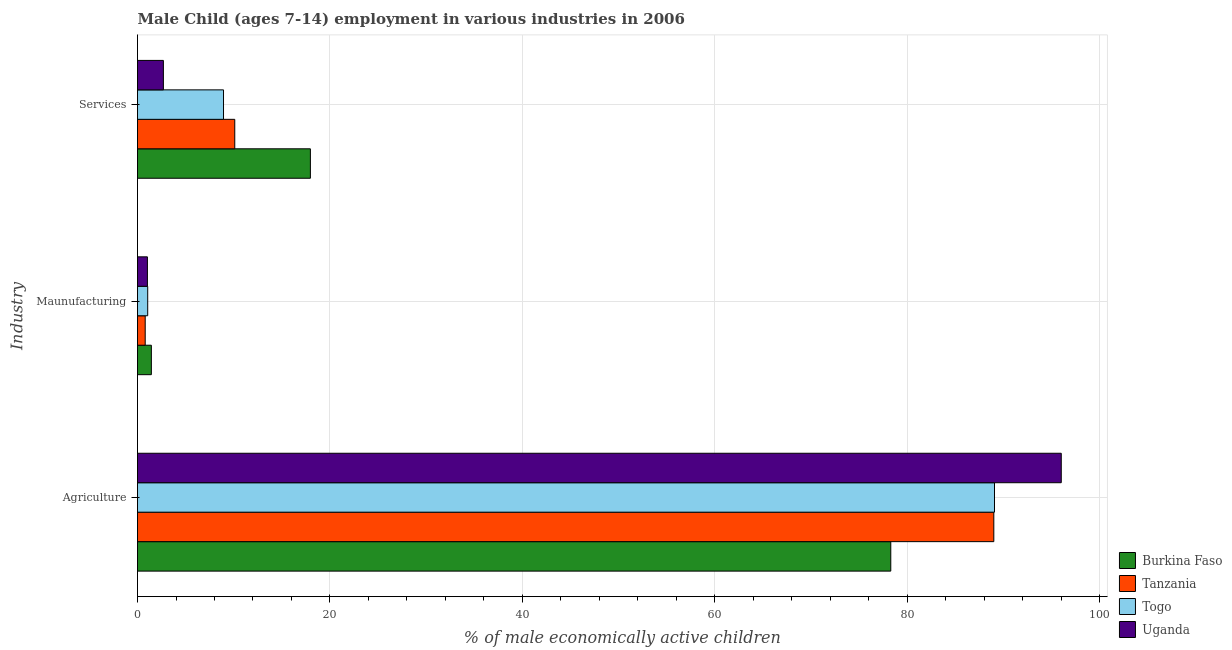How many bars are there on the 2nd tick from the top?
Give a very brief answer. 4. What is the label of the 1st group of bars from the top?
Provide a short and direct response. Services. What is the percentage of economically active children in services in Togo?
Your answer should be compact. 8.94. Across all countries, what is the maximum percentage of economically active children in agriculture?
Ensure brevity in your answer.  96.02. Across all countries, what is the minimum percentage of economically active children in services?
Keep it short and to the point. 2.69. In which country was the percentage of economically active children in agriculture maximum?
Provide a short and direct response. Uganda. In which country was the percentage of economically active children in agriculture minimum?
Your answer should be very brief. Burkina Faso. What is the total percentage of economically active children in manufacturing in the graph?
Provide a succinct answer. 4.33. What is the difference between the percentage of economically active children in services in Togo and that in Tanzania?
Provide a succinct answer. -1.17. What is the difference between the percentage of economically active children in manufacturing in Togo and the percentage of economically active children in agriculture in Burkina Faso?
Ensure brevity in your answer.  -77.24. What is the average percentage of economically active children in manufacturing per country?
Keep it short and to the point. 1.08. What is the difference between the percentage of economically active children in services and percentage of economically active children in manufacturing in Uganda?
Your answer should be compact. 1.66. What is the ratio of the percentage of economically active children in services in Togo to that in Uganda?
Give a very brief answer. 3.32. Is the percentage of economically active children in manufacturing in Tanzania less than that in Togo?
Your answer should be very brief. Yes. What is the difference between the highest and the second highest percentage of economically active children in manufacturing?
Keep it short and to the point. 0.38. What is the difference between the highest and the lowest percentage of economically active children in manufacturing?
Your answer should be compact. 0.64. Is the sum of the percentage of economically active children in agriculture in Burkina Faso and Tanzania greater than the maximum percentage of economically active children in services across all countries?
Your response must be concise. Yes. What does the 4th bar from the top in Agriculture represents?
Your answer should be very brief. Burkina Faso. What does the 3rd bar from the bottom in Agriculture represents?
Offer a very short reply. Togo. How many bars are there?
Your response must be concise. 12. How many countries are there in the graph?
Offer a very short reply. 4. Are the values on the major ticks of X-axis written in scientific E-notation?
Ensure brevity in your answer.  No. Does the graph contain any zero values?
Give a very brief answer. No. How are the legend labels stacked?
Give a very brief answer. Vertical. What is the title of the graph?
Your response must be concise. Male Child (ages 7-14) employment in various industries in 2006. Does "South Africa" appear as one of the legend labels in the graph?
Provide a short and direct response. No. What is the label or title of the X-axis?
Offer a terse response. % of male economically active children. What is the label or title of the Y-axis?
Give a very brief answer. Industry. What is the % of male economically active children in Burkina Faso in Agriculture?
Your response must be concise. 78.3. What is the % of male economically active children of Tanzania in Agriculture?
Your answer should be compact. 89.01. What is the % of male economically active children in Togo in Agriculture?
Offer a terse response. 89.08. What is the % of male economically active children of Uganda in Agriculture?
Provide a succinct answer. 96.02. What is the % of male economically active children of Burkina Faso in Maunufacturing?
Offer a terse response. 1.44. What is the % of male economically active children in Tanzania in Maunufacturing?
Ensure brevity in your answer.  0.8. What is the % of male economically active children of Togo in Maunufacturing?
Your answer should be very brief. 1.06. What is the % of male economically active children of Uganda in Maunufacturing?
Your answer should be very brief. 1.03. What is the % of male economically active children of Burkina Faso in Services?
Keep it short and to the point. 17.97. What is the % of male economically active children of Tanzania in Services?
Ensure brevity in your answer.  10.11. What is the % of male economically active children in Togo in Services?
Ensure brevity in your answer.  8.94. What is the % of male economically active children in Uganda in Services?
Your answer should be very brief. 2.69. Across all Industry, what is the maximum % of male economically active children of Burkina Faso?
Provide a succinct answer. 78.3. Across all Industry, what is the maximum % of male economically active children of Tanzania?
Your answer should be very brief. 89.01. Across all Industry, what is the maximum % of male economically active children in Togo?
Provide a succinct answer. 89.08. Across all Industry, what is the maximum % of male economically active children of Uganda?
Offer a very short reply. 96.02. Across all Industry, what is the minimum % of male economically active children of Burkina Faso?
Offer a terse response. 1.44. Across all Industry, what is the minimum % of male economically active children in Togo?
Your response must be concise. 1.06. What is the total % of male economically active children in Burkina Faso in the graph?
Keep it short and to the point. 97.71. What is the total % of male economically active children of Tanzania in the graph?
Your answer should be very brief. 99.92. What is the total % of male economically active children of Togo in the graph?
Provide a succinct answer. 99.08. What is the total % of male economically active children of Uganda in the graph?
Give a very brief answer. 99.74. What is the difference between the % of male economically active children in Burkina Faso in Agriculture and that in Maunufacturing?
Offer a terse response. 76.86. What is the difference between the % of male economically active children of Tanzania in Agriculture and that in Maunufacturing?
Make the answer very short. 88.21. What is the difference between the % of male economically active children in Togo in Agriculture and that in Maunufacturing?
Your response must be concise. 88.02. What is the difference between the % of male economically active children in Uganda in Agriculture and that in Maunufacturing?
Your response must be concise. 94.99. What is the difference between the % of male economically active children of Burkina Faso in Agriculture and that in Services?
Make the answer very short. 60.33. What is the difference between the % of male economically active children of Tanzania in Agriculture and that in Services?
Offer a very short reply. 78.9. What is the difference between the % of male economically active children in Togo in Agriculture and that in Services?
Make the answer very short. 80.14. What is the difference between the % of male economically active children of Uganda in Agriculture and that in Services?
Ensure brevity in your answer.  93.33. What is the difference between the % of male economically active children of Burkina Faso in Maunufacturing and that in Services?
Provide a succinct answer. -16.53. What is the difference between the % of male economically active children in Tanzania in Maunufacturing and that in Services?
Provide a short and direct response. -9.31. What is the difference between the % of male economically active children of Togo in Maunufacturing and that in Services?
Provide a short and direct response. -7.88. What is the difference between the % of male economically active children in Uganda in Maunufacturing and that in Services?
Provide a succinct answer. -1.66. What is the difference between the % of male economically active children of Burkina Faso in Agriculture and the % of male economically active children of Tanzania in Maunufacturing?
Offer a terse response. 77.5. What is the difference between the % of male economically active children in Burkina Faso in Agriculture and the % of male economically active children in Togo in Maunufacturing?
Keep it short and to the point. 77.24. What is the difference between the % of male economically active children in Burkina Faso in Agriculture and the % of male economically active children in Uganda in Maunufacturing?
Provide a succinct answer. 77.27. What is the difference between the % of male economically active children in Tanzania in Agriculture and the % of male economically active children in Togo in Maunufacturing?
Give a very brief answer. 87.95. What is the difference between the % of male economically active children in Tanzania in Agriculture and the % of male economically active children in Uganda in Maunufacturing?
Your response must be concise. 87.98. What is the difference between the % of male economically active children of Togo in Agriculture and the % of male economically active children of Uganda in Maunufacturing?
Your response must be concise. 88.05. What is the difference between the % of male economically active children of Burkina Faso in Agriculture and the % of male economically active children of Tanzania in Services?
Make the answer very short. 68.19. What is the difference between the % of male economically active children of Burkina Faso in Agriculture and the % of male economically active children of Togo in Services?
Ensure brevity in your answer.  69.36. What is the difference between the % of male economically active children of Burkina Faso in Agriculture and the % of male economically active children of Uganda in Services?
Give a very brief answer. 75.61. What is the difference between the % of male economically active children of Tanzania in Agriculture and the % of male economically active children of Togo in Services?
Make the answer very short. 80.07. What is the difference between the % of male economically active children of Tanzania in Agriculture and the % of male economically active children of Uganda in Services?
Ensure brevity in your answer.  86.32. What is the difference between the % of male economically active children in Togo in Agriculture and the % of male economically active children in Uganda in Services?
Your answer should be compact. 86.39. What is the difference between the % of male economically active children of Burkina Faso in Maunufacturing and the % of male economically active children of Tanzania in Services?
Provide a succinct answer. -8.67. What is the difference between the % of male economically active children of Burkina Faso in Maunufacturing and the % of male economically active children of Uganda in Services?
Keep it short and to the point. -1.25. What is the difference between the % of male economically active children in Tanzania in Maunufacturing and the % of male economically active children in Togo in Services?
Give a very brief answer. -8.14. What is the difference between the % of male economically active children of Tanzania in Maunufacturing and the % of male economically active children of Uganda in Services?
Your answer should be compact. -1.89. What is the difference between the % of male economically active children in Togo in Maunufacturing and the % of male economically active children in Uganda in Services?
Keep it short and to the point. -1.63. What is the average % of male economically active children in Burkina Faso per Industry?
Provide a short and direct response. 32.57. What is the average % of male economically active children in Tanzania per Industry?
Your answer should be compact. 33.31. What is the average % of male economically active children in Togo per Industry?
Keep it short and to the point. 33.03. What is the average % of male economically active children of Uganda per Industry?
Provide a short and direct response. 33.25. What is the difference between the % of male economically active children of Burkina Faso and % of male economically active children of Tanzania in Agriculture?
Make the answer very short. -10.71. What is the difference between the % of male economically active children in Burkina Faso and % of male economically active children in Togo in Agriculture?
Provide a succinct answer. -10.78. What is the difference between the % of male economically active children of Burkina Faso and % of male economically active children of Uganda in Agriculture?
Offer a very short reply. -17.72. What is the difference between the % of male economically active children of Tanzania and % of male economically active children of Togo in Agriculture?
Give a very brief answer. -0.07. What is the difference between the % of male economically active children of Tanzania and % of male economically active children of Uganda in Agriculture?
Offer a terse response. -7.01. What is the difference between the % of male economically active children of Togo and % of male economically active children of Uganda in Agriculture?
Your response must be concise. -6.94. What is the difference between the % of male economically active children of Burkina Faso and % of male economically active children of Tanzania in Maunufacturing?
Give a very brief answer. 0.64. What is the difference between the % of male economically active children in Burkina Faso and % of male economically active children in Togo in Maunufacturing?
Make the answer very short. 0.38. What is the difference between the % of male economically active children of Burkina Faso and % of male economically active children of Uganda in Maunufacturing?
Offer a very short reply. 0.41. What is the difference between the % of male economically active children in Tanzania and % of male economically active children in Togo in Maunufacturing?
Offer a very short reply. -0.26. What is the difference between the % of male economically active children in Tanzania and % of male economically active children in Uganda in Maunufacturing?
Offer a very short reply. -0.23. What is the difference between the % of male economically active children of Burkina Faso and % of male economically active children of Tanzania in Services?
Your answer should be very brief. 7.86. What is the difference between the % of male economically active children in Burkina Faso and % of male economically active children in Togo in Services?
Offer a terse response. 9.03. What is the difference between the % of male economically active children in Burkina Faso and % of male economically active children in Uganda in Services?
Provide a short and direct response. 15.28. What is the difference between the % of male economically active children in Tanzania and % of male economically active children in Togo in Services?
Ensure brevity in your answer.  1.17. What is the difference between the % of male economically active children of Tanzania and % of male economically active children of Uganda in Services?
Provide a short and direct response. 7.42. What is the difference between the % of male economically active children of Togo and % of male economically active children of Uganda in Services?
Ensure brevity in your answer.  6.25. What is the ratio of the % of male economically active children of Burkina Faso in Agriculture to that in Maunufacturing?
Provide a short and direct response. 54.38. What is the ratio of the % of male economically active children in Tanzania in Agriculture to that in Maunufacturing?
Provide a short and direct response. 111.26. What is the ratio of the % of male economically active children of Togo in Agriculture to that in Maunufacturing?
Offer a very short reply. 84.04. What is the ratio of the % of male economically active children of Uganda in Agriculture to that in Maunufacturing?
Provide a short and direct response. 93.22. What is the ratio of the % of male economically active children of Burkina Faso in Agriculture to that in Services?
Ensure brevity in your answer.  4.36. What is the ratio of the % of male economically active children in Tanzania in Agriculture to that in Services?
Give a very brief answer. 8.8. What is the ratio of the % of male economically active children of Togo in Agriculture to that in Services?
Offer a terse response. 9.96. What is the ratio of the % of male economically active children of Uganda in Agriculture to that in Services?
Ensure brevity in your answer.  35.7. What is the ratio of the % of male economically active children in Burkina Faso in Maunufacturing to that in Services?
Make the answer very short. 0.08. What is the ratio of the % of male economically active children in Tanzania in Maunufacturing to that in Services?
Your answer should be compact. 0.08. What is the ratio of the % of male economically active children of Togo in Maunufacturing to that in Services?
Your answer should be very brief. 0.12. What is the ratio of the % of male economically active children in Uganda in Maunufacturing to that in Services?
Ensure brevity in your answer.  0.38. What is the difference between the highest and the second highest % of male economically active children of Burkina Faso?
Provide a succinct answer. 60.33. What is the difference between the highest and the second highest % of male economically active children of Tanzania?
Provide a short and direct response. 78.9. What is the difference between the highest and the second highest % of male economically active children of Togo?
Your answer should be compact. 80.14. What is the difference between the highest and the second highest % of male economically active children of Uganda?
Your response must be concise. 93.33. What is the difference between the highest and the lowest % of male economically active children of Burkina Faso?
Make the answer very short. 76.86. What is the difference between the highest and the lowest % of male economically active children in Tanzania?
Offer a very short reply. 88.21. What is the difference between the highest and the lowest % of male economically active children in Togo?
Your answer should be compact. 88.02. What is the difference between the highest and the lowest % of male economically active children in Uganda?
Your answer should be very brief. 94.99. 